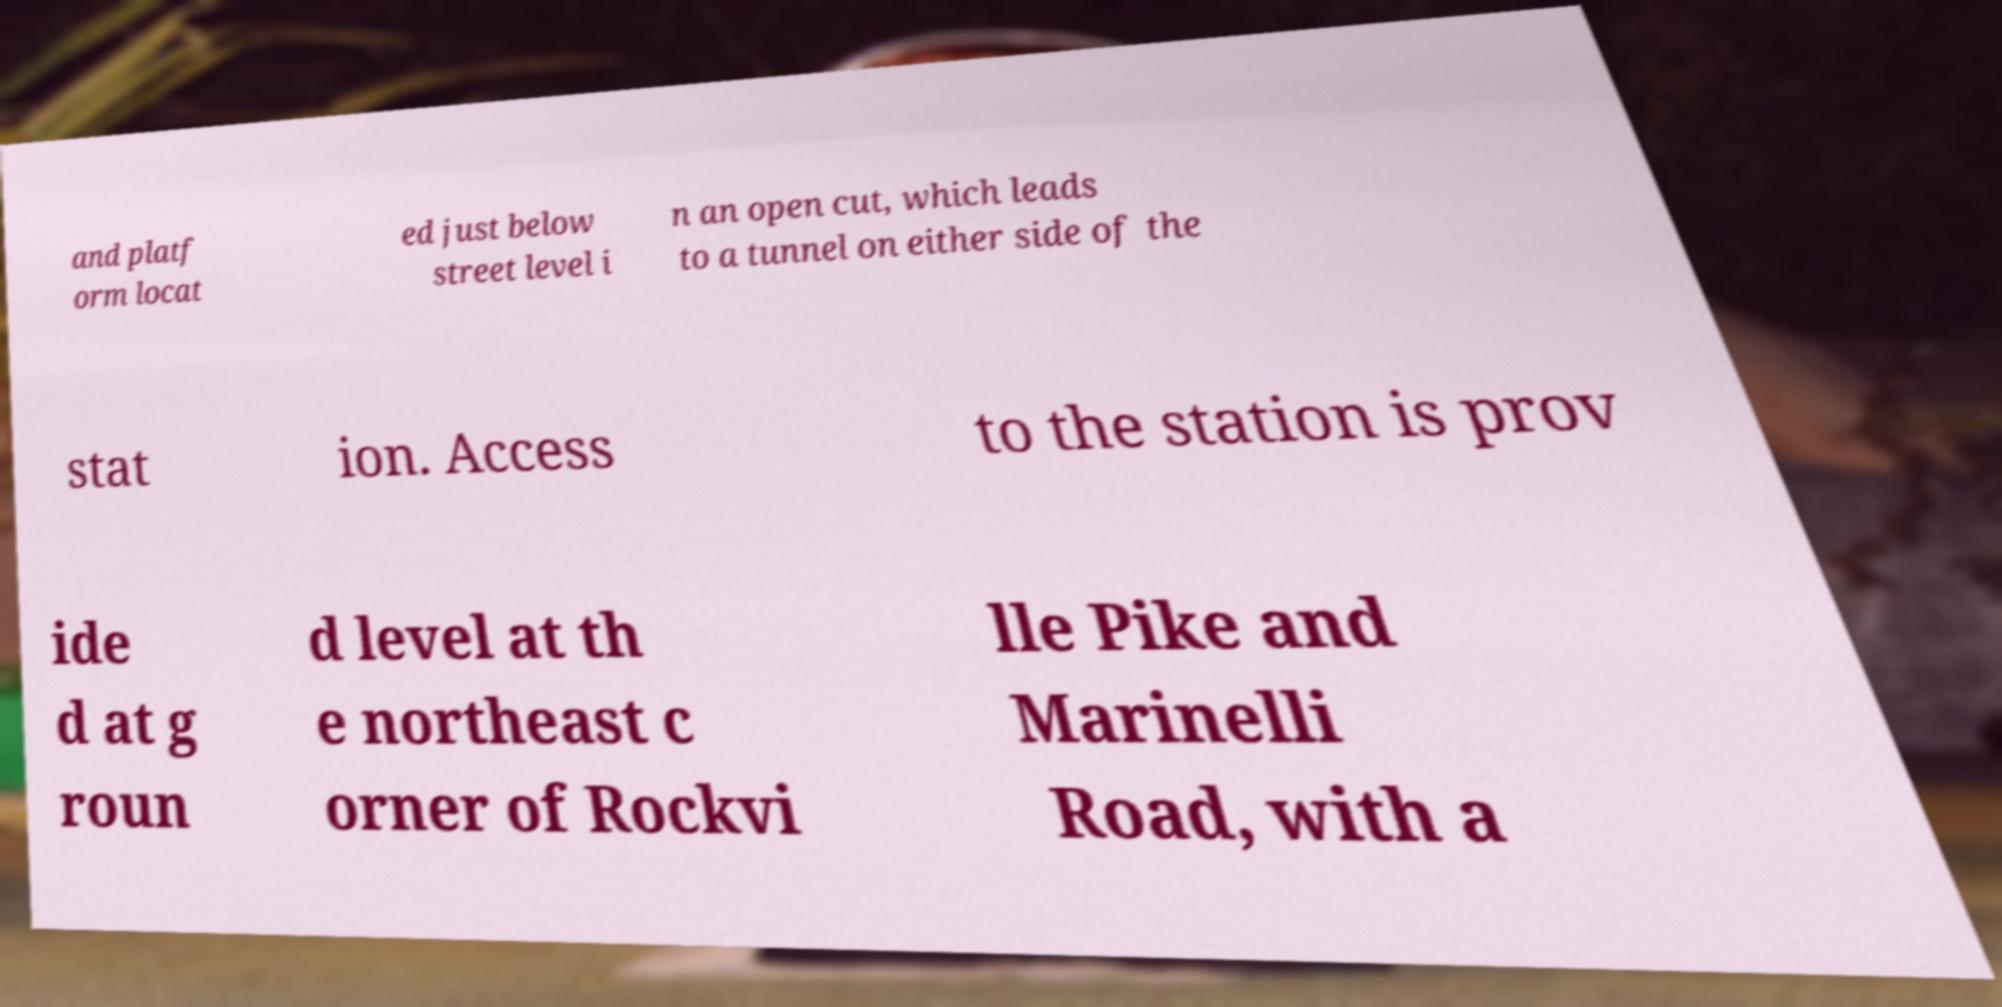For documentation purposes, I need the text within this image transcribed. Could you provide that? and platf orm locat ed just below street level i n an open cut, which leads to a tunnel on either side of the stat ion. Access to the station is prov ide d at g roun d level at th e northeast c orner of Rockvi lle Pike and Marinelli Road, with a 